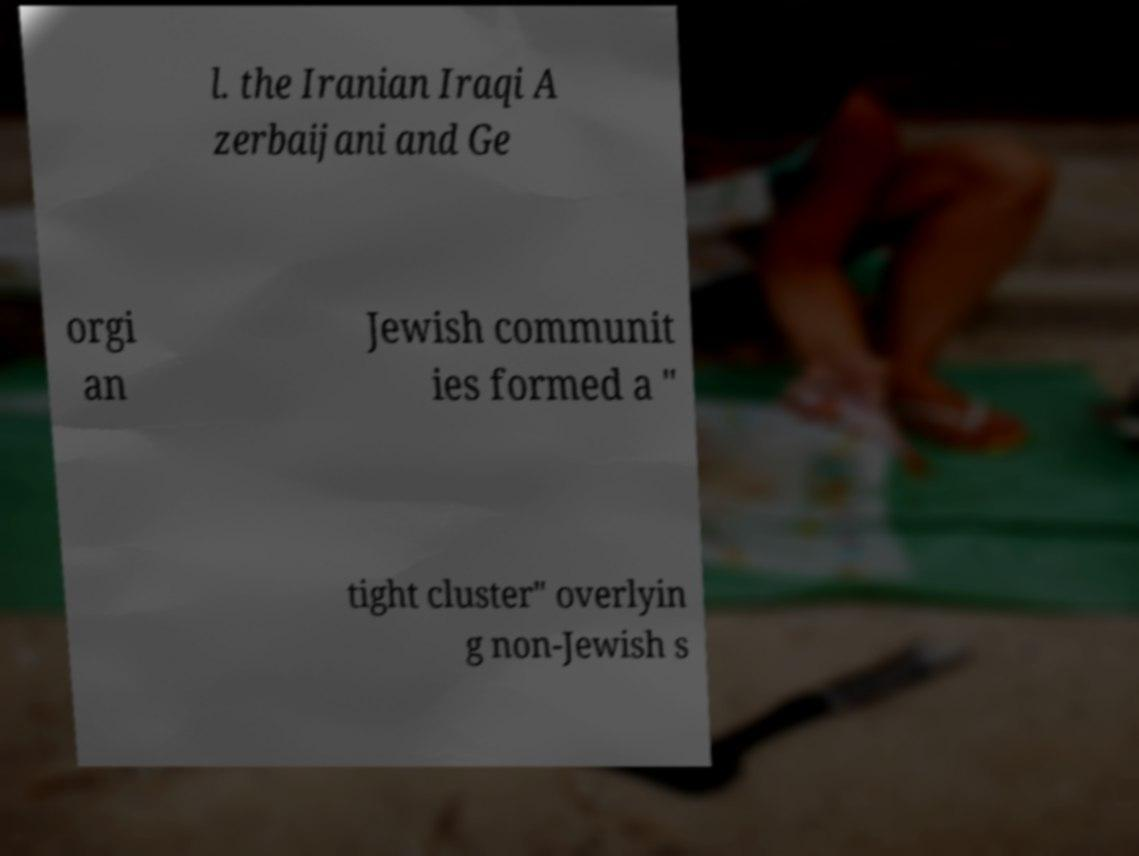There's text embedded in this image that I need extracted. Can you transcribe it verbatim? l. the Iranian Iraqi A zerbaijani and Ge orgi an Jewish communit ies formed a " tight cluster" overlyin g non-Jewish s 